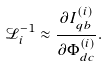Convert formula to latex. <formula><loc_0><loc_0><loc_500><loc_500>\mathcal { L } _ { i } ^ { - 1 } \approx \frac { \partial I _ { q b } ^ { ( i ) } } { \partial \Phi _ { d c } ^ { ( i ) } } .</formula> 